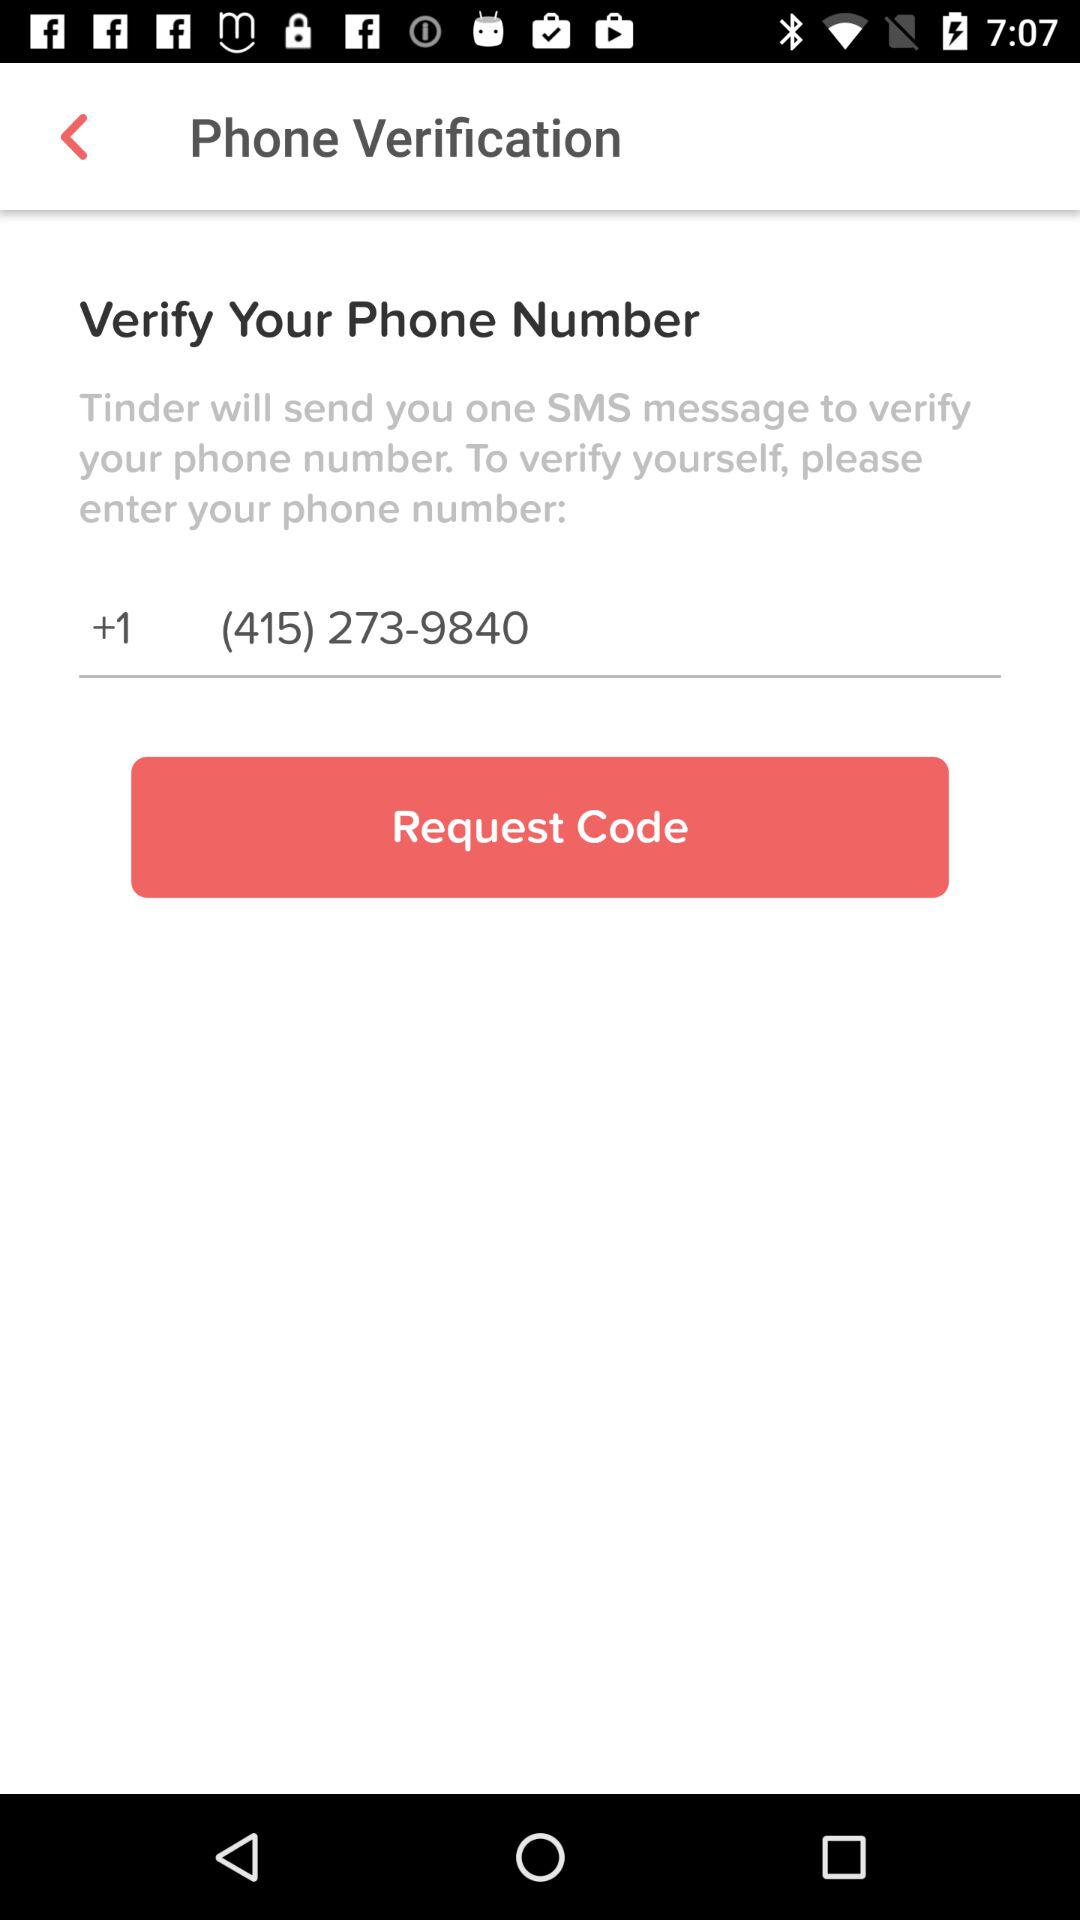What is the requirement for self-verification? The requirement for self-verification is to enter your phone number. 